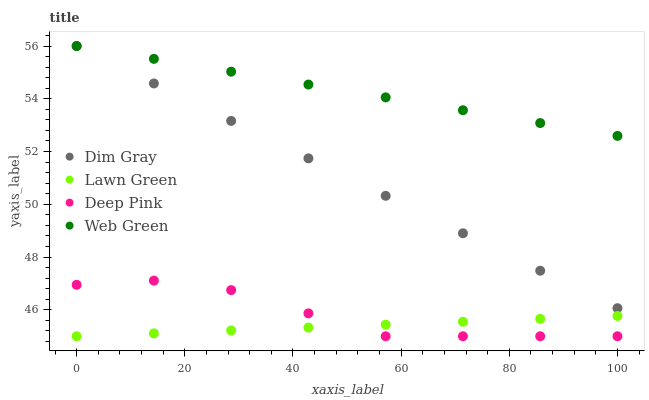Does Lawn Green have the minimum area under the curve?
Answer yes or no. Yes. Does Web Green have the maximum area under the curve?
Answer yes or no. Yes. Does Dim Gray have the minimum area under the curve?
Answer yes or no. No. Does Dim Gray have the maximum area under the curve?
Answer yes or no. No. Is Lawn Green the smoothest?
Answer yes or no. Yes. Is Deep Pink the roughest?
Answer yes or no. Yes. Is Dim Gray the smoothest?
Answer yes or no. No. Is Dim Gray the roughest?
Answer yes or no. No. Does Lawn Green have the lowest value?
Answer yes or no. Yes. Does Dim Gray have the lowest value?
Answer yes or no. No. Does Web Green have the highest value?
Answer yes or no. Yes. Does Deep Pink have the highest value?
Answer yes or no. No. Is Deep Pink less than Dim Gray?
Answer yes or no. Yes. Is Web Green greater than Deep Pink?
Answer yes or no. Yes. Does Web Green intersect Dim Gray?
Answer yes or no. Yes. Is Web Green less than Dim Gray?
Answer yes or no. No. Is Web Green greater than Dim Gray?
Answer yes or no. No. Does Deep Pink intersect Dim Gray?
Answer yes or no. No. 